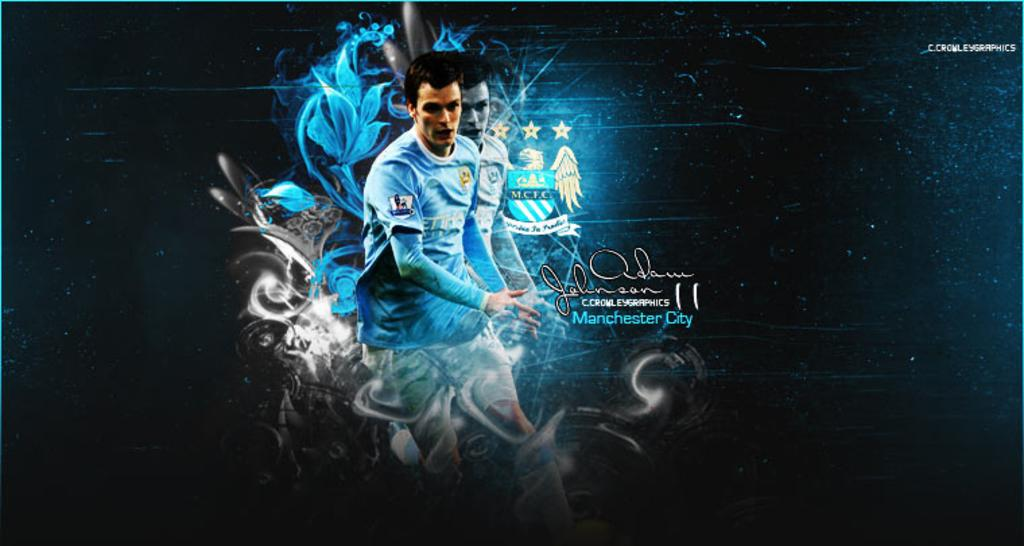<image>
Describe the image concisely. Ad advertisement for Manchester City football shows a man in a blue jersey with swirls around him. 